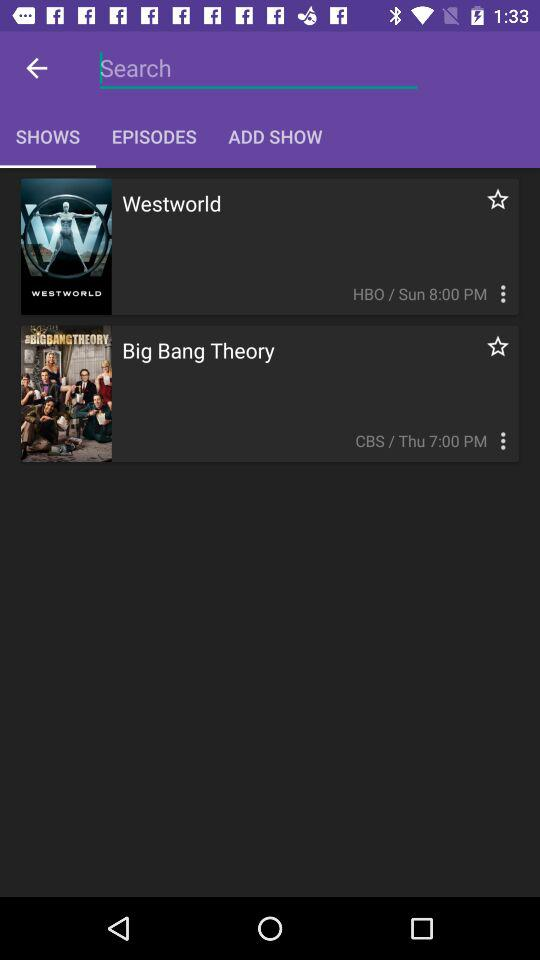What are the shows' names? The shows' names are "Westworld" and "Big Bang Theory". 